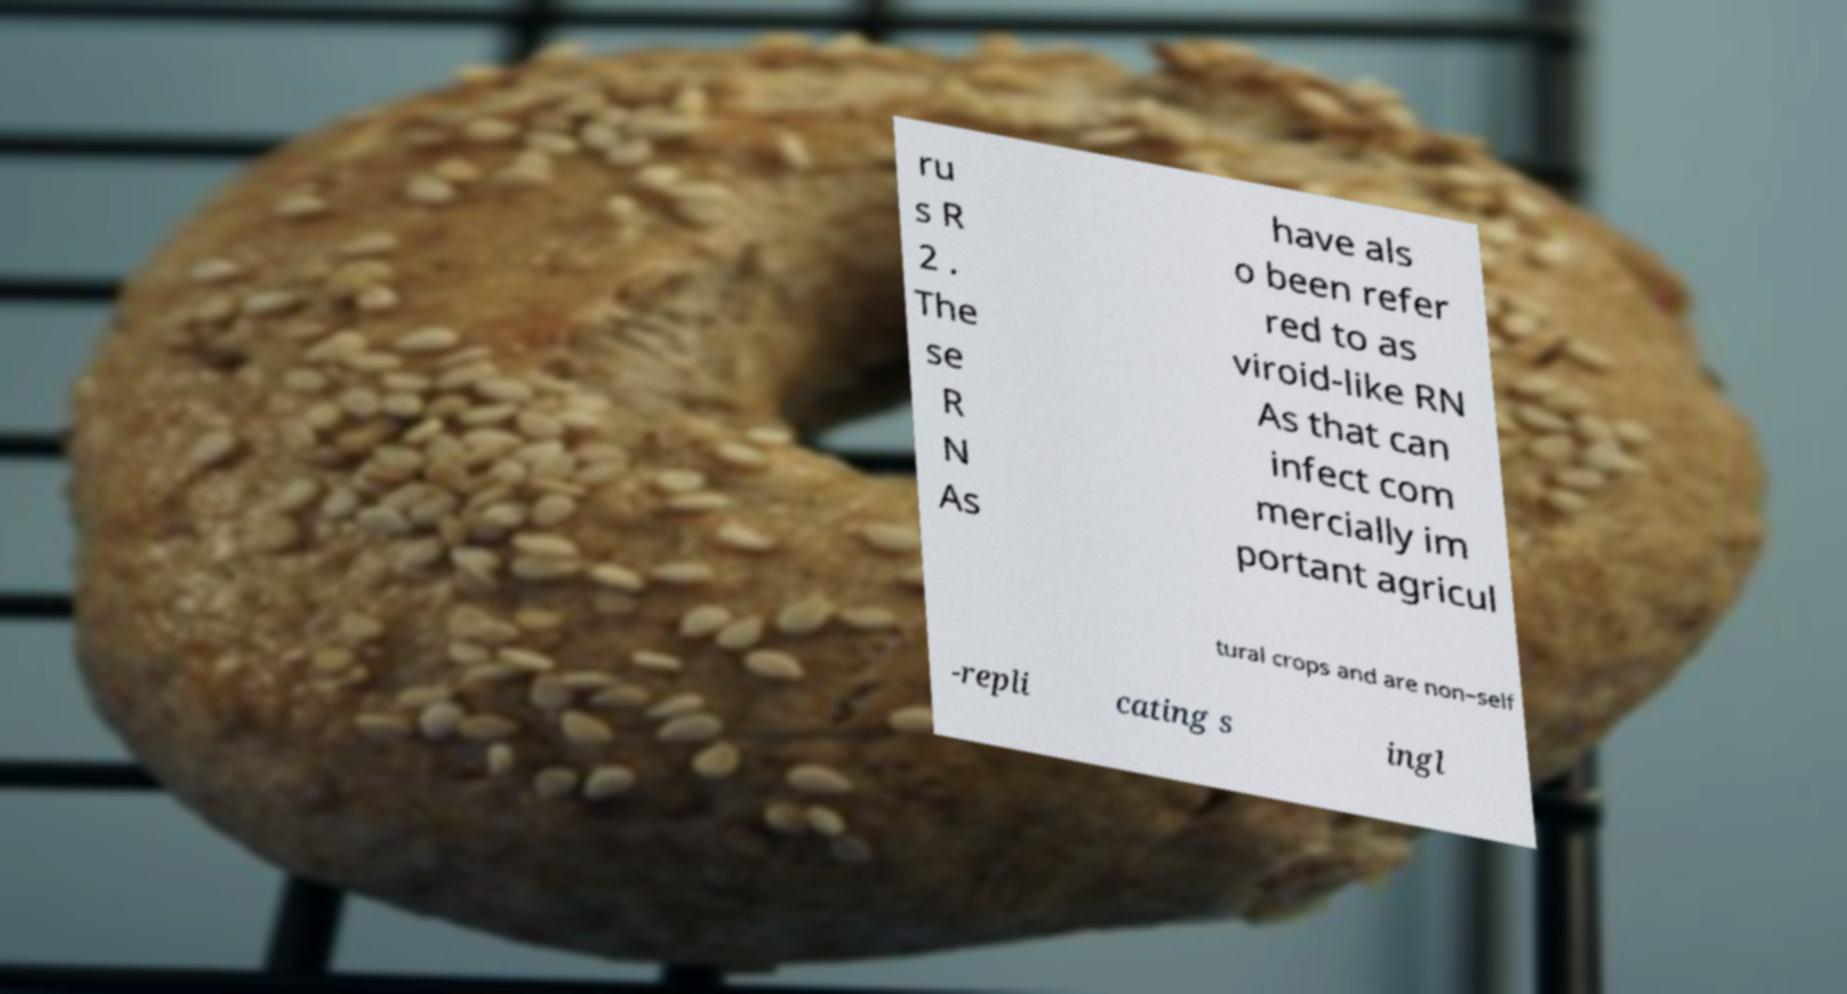What messages or text are displayed in this image? I need them in a readable, typed format. ru s R 2 . The se R N As have als o been refer red to as viroid-like RN As that can infect com mercially im portant agricul tural crops and are non–self -repli cating s ingl 